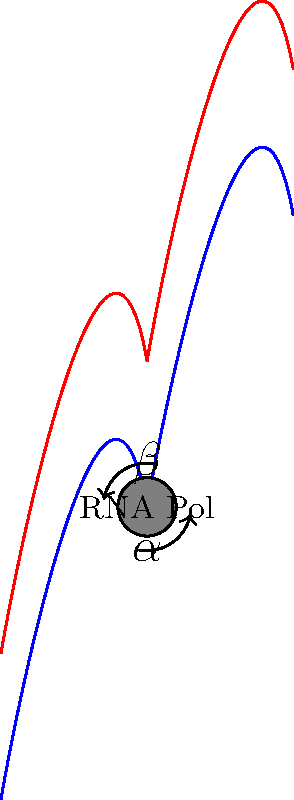During transcription, the DNA double helix partially unwinds to allow RNA polymerase access to the template strand. In the diagram, angle $\alpha$ represents the unwinding angle, and angle $\beta$ represents the complementary angle. If the total rotation angle of a complete turn in the B-form DNA double helix is 360°, and $\alpha = 18°$, what is the value of $\beta$? To solve this problem, let's follow these steps:

1. Recall that B-form DNA, the most common form in living organisms, completes a full turn every 360°.

2. During transcription, the DNA partially unwinds to form a transcription bubble. This unwinding is represented by angle $\alpha$ in the diagram.

3. The complementary angle to this unwinding is represented by $\beta$.

4. We know that $\alpha = 18°$.

5. In a complete turn of 360°, the sum of $\alpha$ and $\beta$ must equal 360°:

   $\alpha + \beta = 360°$

6. Substituting the known value of $\alpha$:

   $18° + \beta = 360°$

7. Solve for $\beta$:

   $\beta = 360° - 18°$
   $\beta = 342°$

Therefore, the value of angle $\beta$ is 342°.
Answer: 342° 